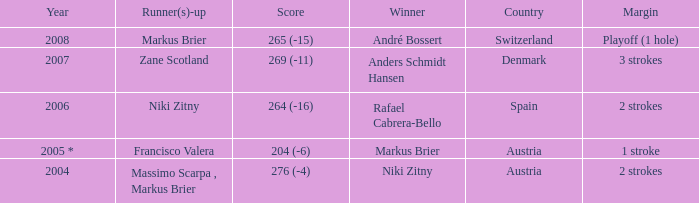Who was the runner-up when the margin was 1 stroke? Francisco Valera. Parse the table in full. {'header': ['Year', 'Runner(s)-up', 'Score', 'Winner', 'Country', 'Margin'], 'rows': [['2008', 'Markus Brier', '265 (-15)', 'André Bossert', 'Switzerland', 'Playoff (1 hole)'], ['2007', 'Zane Scotland', '269 (-11)', 'Anders Schmidt Hansen', 'Denmark', '3 strokes'], ['2006', 'Niki Zitny', '264 (-16)', 'Rafael Cabrera-Bello', 'Spain', '2 strokes'], ['2005 *', 'Francisco Valera', '204 (-6)', 'Markus Brier', 'Austria', '1 stroke'], ['2004', 'Massimo Scarpa , Markus Brier', '276 (-4)', 'Niki Zitny', 'Austria', '2 strokes']]} 